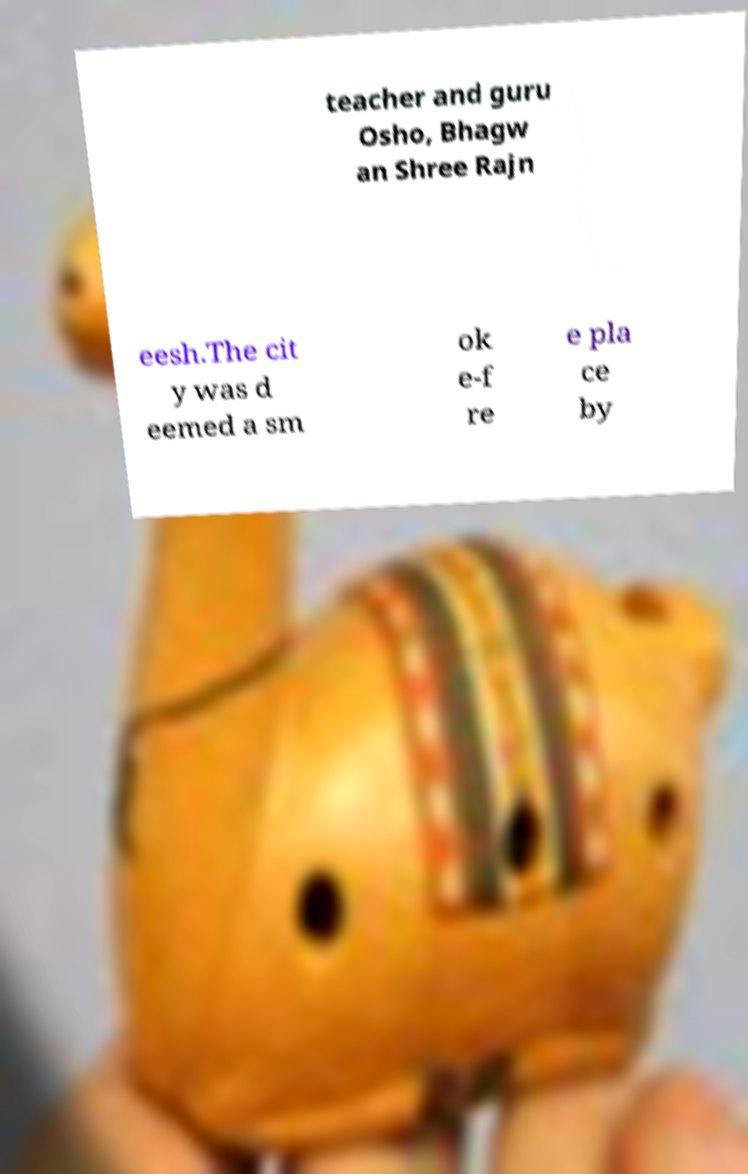Can you read and provide the text displayed in the image?This photo seems to have some interesting text. Can you extract and type it out for me? teacher and guru Osho, Bhagw an Shree Rajn eesh.The cit y was d eemed a sm ok e-f re e pla ce by 